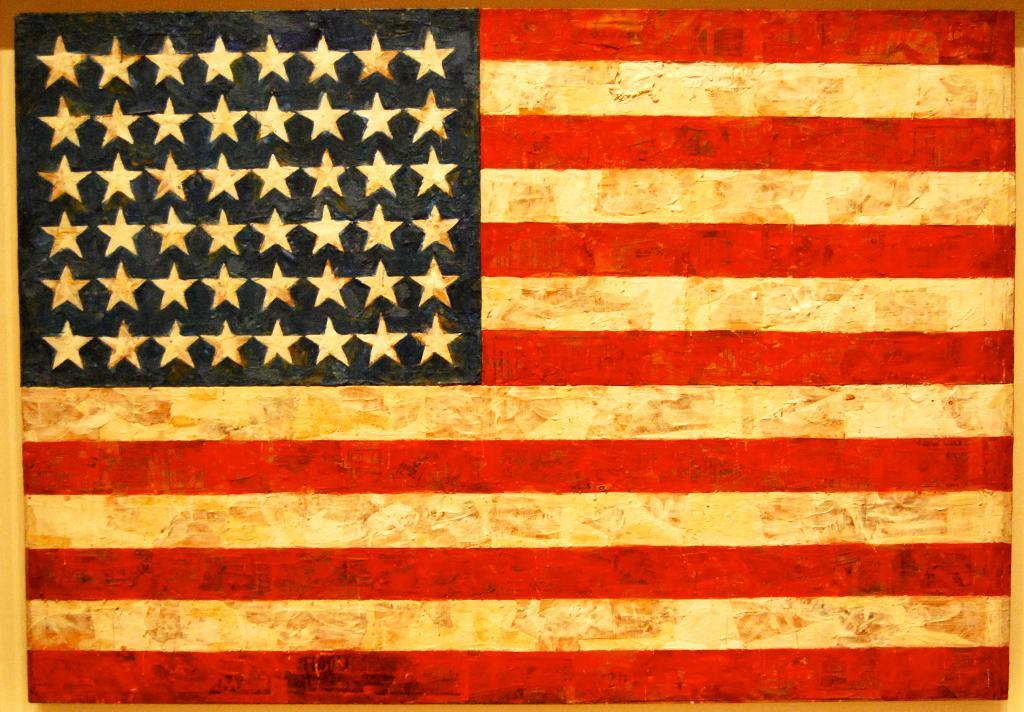What is depicted on the wooden surface in the image? There is a flag painted on a wooden surface in the image. Where is the toothbrush kept in the image? There is no toothbrush present in the image. What type of fireman is shown in the image? There is no fireman depicted in the image; it features a flag painted on a wooden surface. 